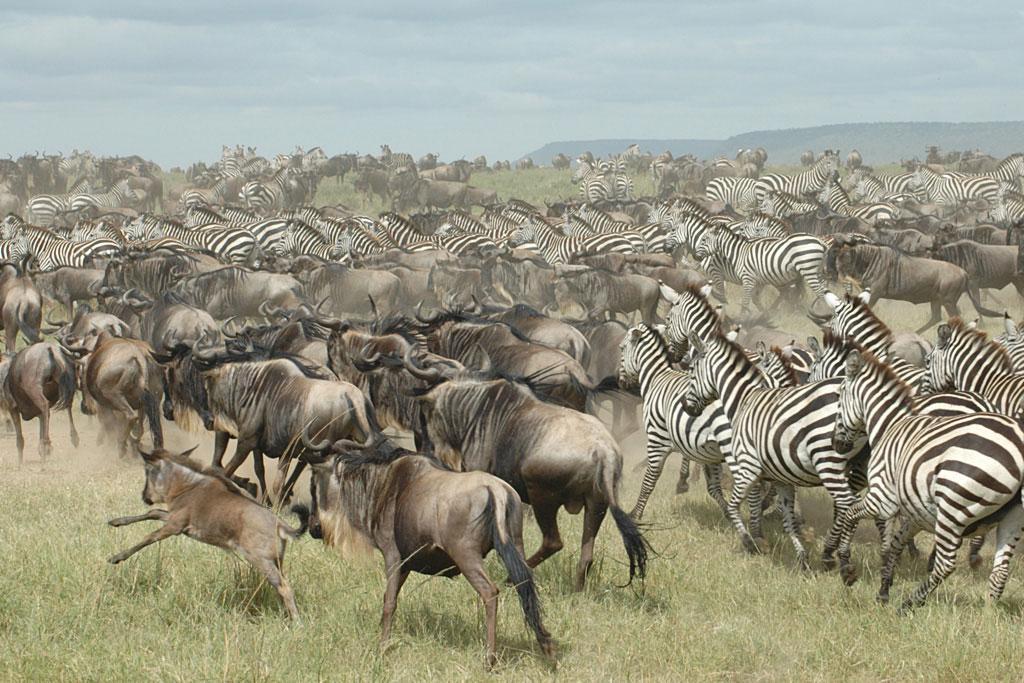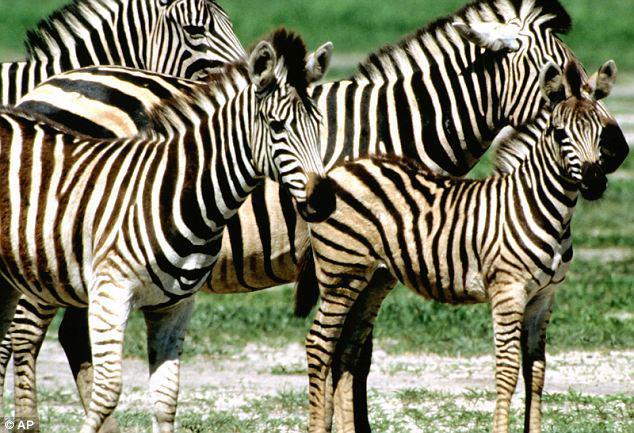The first image is the image on the left, the second image is the image on the right. Assess this claim about the two images: "The animals in both images are near a body of water.". Correct or not? Answer yes or no. No. The first image is the image on the left, the second image is the image on the right. Considering the images on both sides, is "One image shows a row of zebras standing in water with heads lowered to drink." valid? Answer yes or no. No. 